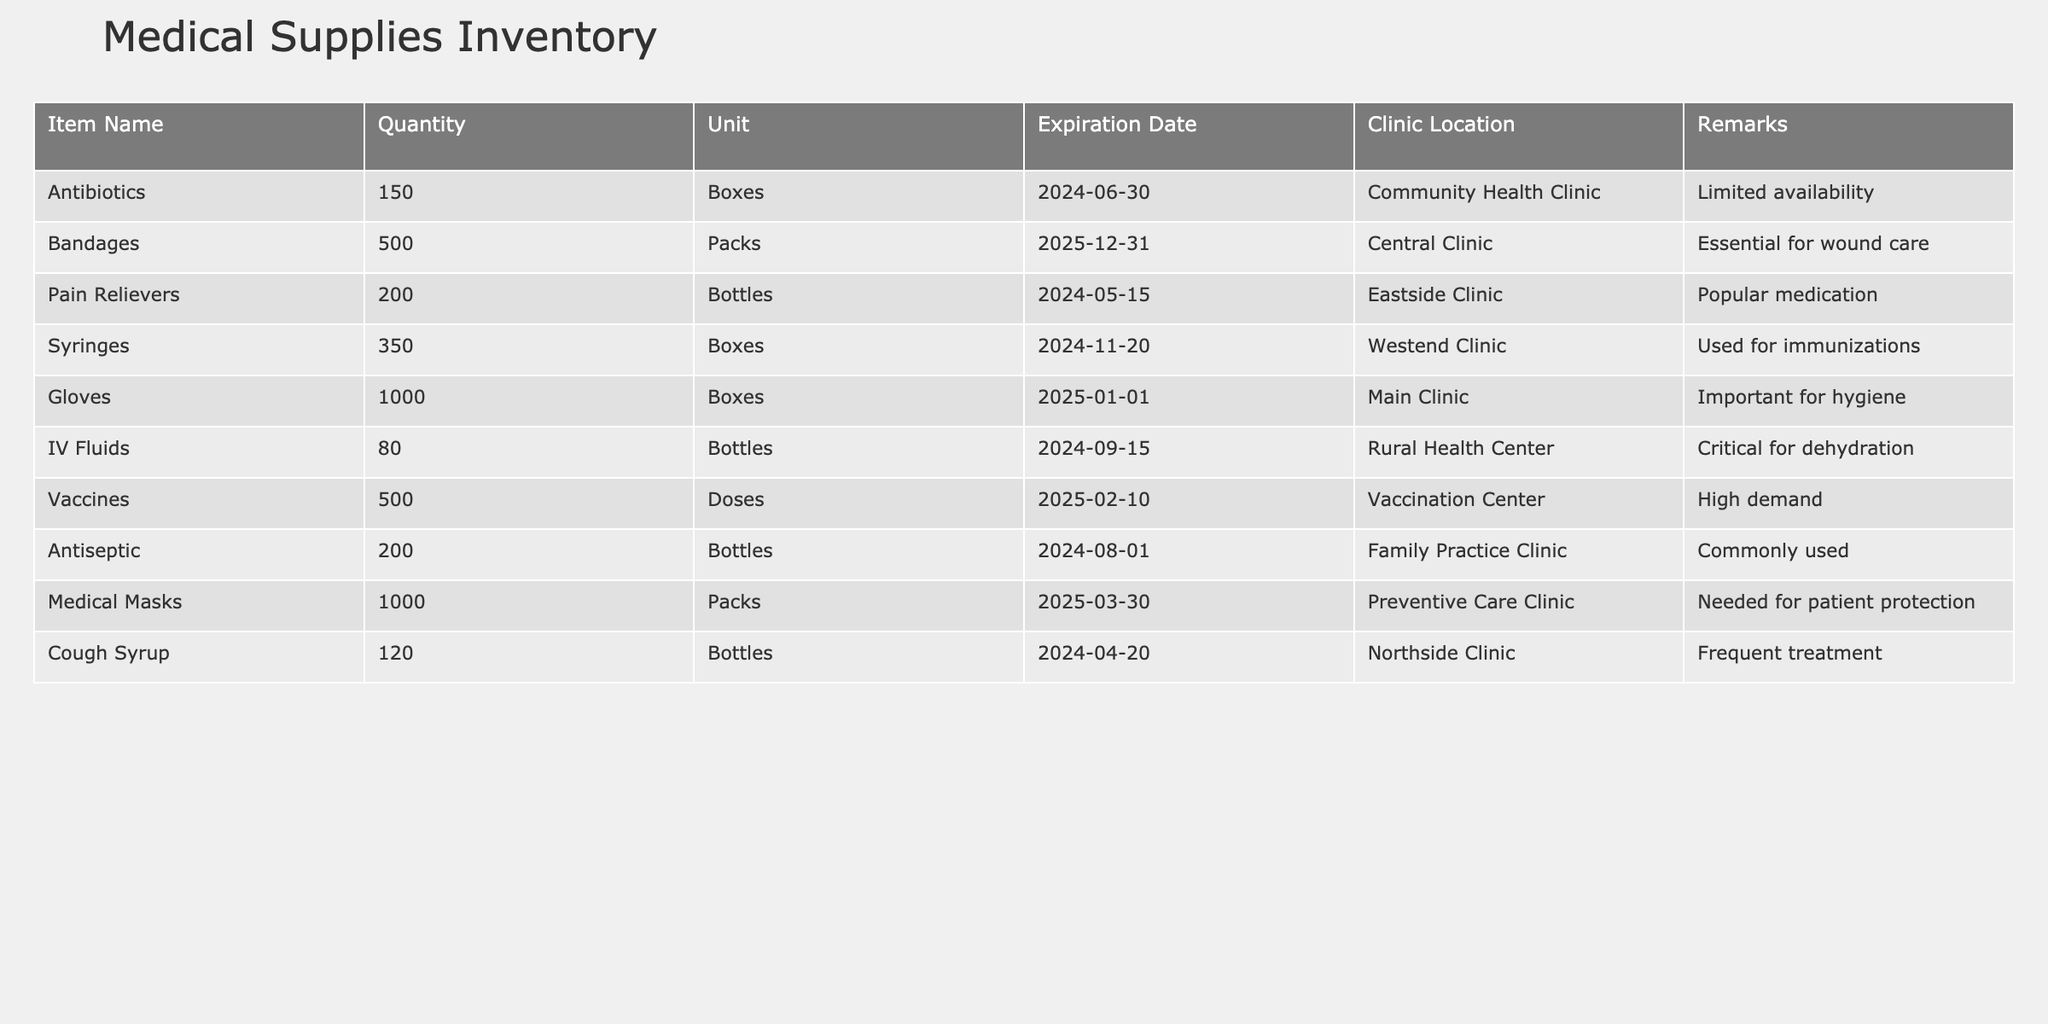What is the total quantity of medical masks available in the inventory? From the table, we see that the quantity of medical masks is listed as 1000 packs. This is a direct retrieval question because the information can be found in a single row of the table.
Answer: 1000 packs Which clinic has the highest number of syringes available? The table shows that the Westend Clinic has 350 boxes of syringes, which is the highest quantity compared to the other clinics listed. This was a retrieval question looking for a specific value from a single data point.
Answer: Westend Clinic What is the total quantity of antibiotics and pain relievers combined? Adding the quantities from the table: antibiotics (150 boxes) + pain relievers (200 bottles) = 350 total units. This involves a simple addition operation with values from two different rows.
Answer: 350 Are IV fluids critical for rural health centers? According to the remarks in the table, IV fluids are labeled as "Critical for dehydration" specifically for the Rural Health Center, which confirms that they are indeed critical. This is a fact-based question that can be answered by directly referring to the data.
Answer: Yes Which medical supply has the earliest expiration date, and where is it located? By looking at the expiration dates in the table, we find that pain relievers expire on May 15, 2024, which is the earliest date listed. Therefore, the pain relievers located at the Eastside Clinic have the earliest expiration. This is a complex reasoning question requiring comparison of multiple dates.
Answer: Pain Relievers at Eastside Clinic How many medical supplies have an expiration date after December 2025? From the table, we can see that all expiration dates listed are before December 2025. Therefore, none of the medical supplies have an expiration date after that. This requires checking all expiration dates and concluding based on the information provided.
Answer: 0 What percentage of total gloves and bandages available is in gloves? The total quantity of gloves is 1000 boxes, and the total quantity of bandages is 500 packs, making the combined total 1500 units. To find the percentage of gloves: (1000 gloves / 1500 total) * 100 = 66.67%. This involves calculations with two different values to find a percentage.
Answer: 66.67% Which clinic has the second-highest quantity of vaccines and what is that quantity? The Vaccination Center has 500 doses of vaccines, and to check for others, we look at the other clinics. No other clinic has a higher number listed for vaccines. Since it is the only entry, it is also the highest. Therefore, it does not have a second-highest quantity because it is the highest overall quantity. This requires sorting through each entry to assess their comparative totals.
Answer: N/A How many packs of bandages are available at Central Clinic? The table states there are 500 packs of bandages available at the Central Clinic, which is a straightforward retrieval of data from a single row.
Answer: 500 packs 